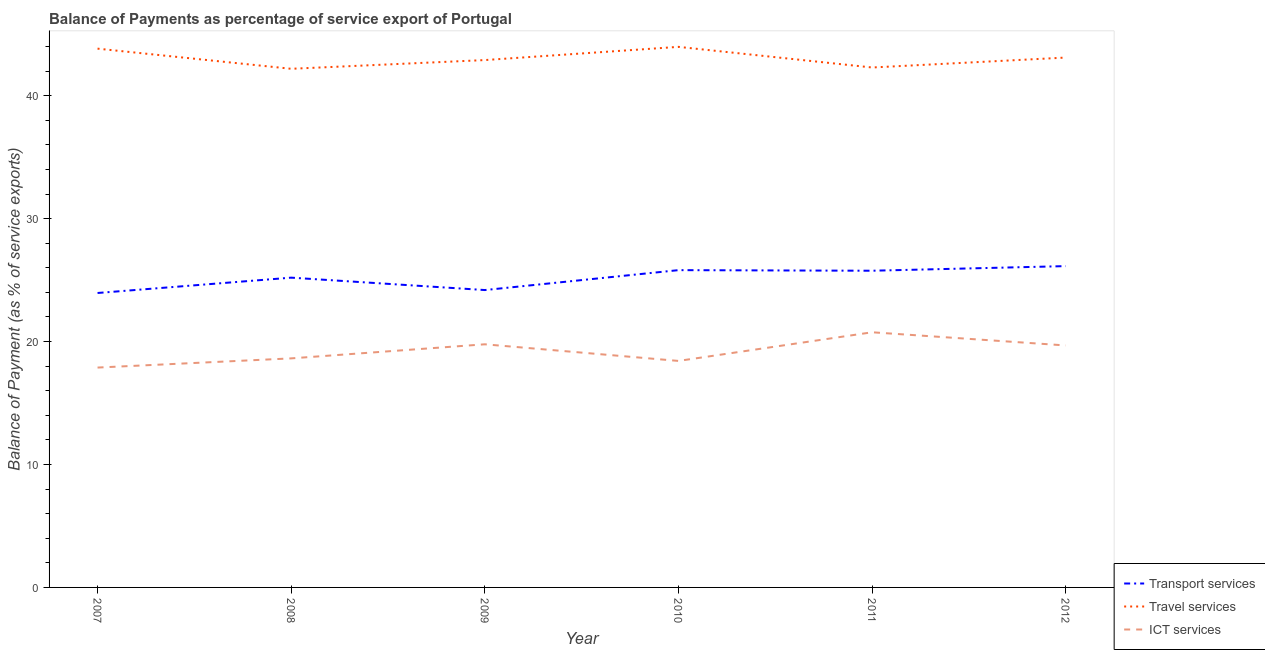How many different coloured lines are there?
Provide a short and direct response. 3. What is the balance of payment of transport services in 2007?
Provide a short and direct response. 23.95. Across all years, what is the maximum balance of payment of travel services?
Offer a terse response. 43.97. Across all years, what is the minimum balance of payment of ict services?
Your answer should be very brief. 17.89. In which year was the balance of payment of travel services maximum?
Give a very brief answer. 2010. What is the total balance of payment of travel services in the graph?
Ensure brevity in your answer.  258.29. What is the difference between the balance of payment of transport services in 2007 and that in 2008?
Give a very brief answer. -1.25. What is the difference between the balance of payment of travel services in 2010 and the balance of payment of transport services in 2011?
Ensure brevity in your answer.  18.21. What is the average balance of payment of transport services per year?
Give a very brief answer. 25.18. In the year 2010, what is the difference between the balance of payment of ict services and balance of payment of transport services?
Make the answer very short. -7.38. In how many years, is the balance of payment of transport services greater than 18 %?
Your answer should be very brief. 6. What is the ratio of the balance of payment of ict services in 2009 to that in 2012?
Your answer should be compact. 1. Is the balance of payment of travel services in 2011 less than that in 2012?
Offer a very short reply. Yes. Is the difference between the balance of payment of ict services in 2010 and 2012 greater than the difference between the balance of payment of travel services in 2010 and 2012?
Give a very brief answer. No. What is the difference between the highest and the second highest balance of payment of travel services?
Ensure brevity in your answer.  0.15. What is the difference between the highest and the lowest balance of payment of transport services?
Give a very brief answer. 2.19. Is the sum of the balance of payment of transport services in 2008 and 2010 greater than the maximum balance of payment of ict services across all years?
Ensure brevity in your answer.  Yes. Is the balance of payment of ict services strictly less than the balance of payment of travel services over the years?
Your response must be concise. Yes. How many years are there in the graph?
Give a very brief answer. 6. Are the values on the major ticks of Y-axis written in scientific E-notation?
Make the answer very short. No. How many legend labels are there?
Give a very brief answer. 3. What is the title of the graph?
Your answer should be compact. Balance of Payments as percentage of service export of Portugal. Does "Social Protection" appear as one of the legend labels in the graph?
Offer a terse response. No. What is the label or title of the Y-axis?
Give a very brief answer. Balance of Payment (as % of service exports). What is the Balance of Payment (as % of service exports) of Transport services in 2007?
Offer a very short reply. 23.95. What is the Balance of Payment (as % of service exports) of Travel services in 2007?
Offer a very short reply. 43.83. What is the Balance of Payment (as % of service exports) in ICT services in 2007?
Offer a terse response. 17.89. What is the Balance of Payment (as % of service exports) in Transport services in 2008?
Your answer should be very brief. 25.2. What is the Balance of Payment (as % of service exports) in Travel services in 2008?
Provide a succinct answer. 42.19. What is the Balance of Payment (as % of service exports) of ICT services in 2008?
Ensure brevity in your answer.  18.63. What is the Balance of Payment (as % of service exports) in Transport services in 2009?
Ensure brevity in your answer.  24.19. What is the Balance of Payment (as % of service exports) of Travel services in 2009?
Make the answer very short. 42.9. What is the Balance of Payment (as % of service exports) of ICT services in 2009?
Offer a very short reply. 19.78. What is the Balance of Payment (as % of service exports) in Transport services in 2010?
Offer a terse response. 25.81. What is the Balance of Payment (as % of service exports) in Travel services in 2010?
Give a very brief answer. 43.97. What is the Balance of Payment (as % of service exports) in ICT services in 2010?
Keep it short and to the point. 18.43. What is the Balance of Payment (as % of service exports) in Transport services in 2011?
Your answer should be very brief. 25.76. What is the Balance of Payment (as % of service exports) of Travel services in 2011?
Ensure brevity in your answer.  42.3. What is the Balance of Payment (as % of service exports) in ICT services in 2011?
Ensure brevity in your answer.  20.76. What is the Balance of Payment (as % of service exports) of Transport services in 2012?
Ensure brevity in your answer.  26.14. What is the Balance of Payment (as % of service exports) of Travel services in 2012?
Keep it short and to the point. 43.1. What is the Balance of Payment (as % of service exports) of ICT services in 2012?
Ensure brevity in your answer.  19.68. Across all years, what is the maximum Balance of Payment (as % of service exports) of Transport services?
Your answer should be very brief. 26.14. Across all years, what is the maximum Balance of Payment (as % of service exports) of Travel services?
Give a very brief answer. 43.97. Across all years, what is the maximum Balance of Payment (as % of service exports) of ICT services?
Offer a terse response. 20.76. Across all years, what is the minimum Balance of Payment (as % of service exports) in Transport services?
Offer a terse response. 23.95. Across all years, what is the minimum Balance of Payment (as % of service exports) in Travel services?
Your answer should be compact. 42.19. Across all years, what is the minimum Balance of Payment (as % of service exports) in ICT services?
Keep it short and to the point. 17.89. What is the total Balance of Payment (as % of service exports) of Transport services in the graph?
Your answer should be compact. 151.05. What is the total Balance of Payment (as % of service exports) in Travel services in the graph?
Offer a terse response. 258.29. What is the total Balance of Payment (as % of service exports) of ICT services in the graph?
Provide a short and direct response. 115.16. What is the difference between the Balance of Payment (as % of service exports) of Transport services in 2007 and that in 2008?
Your response must be concise. -1.25. What is the difference between the Balance of Payment (as % of service exports) in Travel services in 2007 and that in 2008?
Provide a succinct answer. 1.64. What is the difference between the Balance of Payment (as % of service exports) of ICT services in 2007 and that in 2008?
Ensure brevity in your answer.  -0.75. What is the difference between the Balance of Payment (as % of service exports) in Transport services in 2007 and that in 2009?
Provide a short and direct response. -0.24. What is the difference between the Balance of Payment (as % of service exports) in Travel services in 2007 and that in 2009?
Offer a terse response. 0.93. What is the difference between the Balance of Payment (as % of service exports) of ICT services in 2007 and that in 2009?
Provide a short and direct response. -1.89. What is the difference between the Balance of Payment (as % of service exports) of Transport services in 2007 and that in 2010?
Keep it short and to the point. -1.86. What is the difference between the Balance of Payment (as % of service exports) of Travel services in 2007 and that in 2010?
Provide a succinct answer. -0.14. What is the difference between the Balance of Payment (as % of service exports) of ICT services in 2007 and that in 2010?
Provide a short and direct response. -0.54. What is the difference between the Balance of Payment (as % of service exports) of Transport services in 2007 and that in 2011?
Ensure brevity in your answer.  -1.81. What is the difference between the Balance of Payment (as % of service exports) of Travel services in 2007 and that in 2011?
Offer a very short reply. 1.53. What is the difference between the Balance of Payment (as % of service exports) in ICT services in 2007 and that in 2011?
Keep it short and to the point. -2.87. What is the difference between the Balance of Payment (as % of service exports) of Transport services in 2007 and that in 2012?
Keep it short and to the point. -2.19. What is the difference between the Balance of Payment (as % of service exports) in Travel services in 2007 and that in 2012?
Keep it short and to the point. 0.73. What is the difference between the Balance of Payment (as % of service exports) in ICT services in 2007 and that in 2012?
Your answer should be compact. -1.8. What is the difference between the Balance of Payment (as % of service exports) of Transport services in 2008 and that in 2009?
Keep it short and to the point. 1.01. What is the difference between the Balance of Payment (as % of service exports) in Travel services in 2008 and that in 2009?
Give a very brief answer. -0.71. What is the difference between the Balance of Payment (as % of service exports) in ICT services in 2008 and that in 2009?
Ensure brevity in your answer.  -1.15. What is the difference between the Balance of Payment (as % of service exports) in Transport services in 2008 and that in 2010?
Offer a very short reply. -0.61. What is the difference between the Balance of Payment (as % of service exports) in Travel services in 2008 and that in 2010?
Your answer should be compact. -1.78. What is the difference between the Balance of Payment (as % of service exports) in ICT services in 2008 and that in 2010?
Make the answer very short. 0.21. What is the difference between the Balance of Payment (as % of service exports) in Transport services in 2008 and that in 2011?
Your response must be concise. -0.56. What is the difference between the Balance of Payment (as % of service exports) of Travel services in 2008 and that in 2011?
Offer a terse response. -0.11. What is the difference between the Balance of Payment (as % of service exports) of ICT services in 2008 and that in 2011?
Your answer should be very brief. -2.12. What is the difference between the Balance of Payment (as % of service exports) in Transport services in 2008 and that in 2012?
Provide a short and direct response. -0.94. What is the difference between the Balance of Payment (as % of service exports) in Travel services in 2008 and that in 2012?
Provide a succinct answer. -0.91. What is the difference between the Balance of Payment (as % of service exports) in ICT services in 2008 and that in 2012?
Your answer should be very brief. -1.05. What is the difference between the Balance of Payment (as % of service exports) of Transport services in 2009 and that in 2010?
Your answer should be very brief. -1.62. What is the difference between the Balance of Payment (as % of service exports) of Travel services in 2009 and that in 2010?
Your answer should be compact. -1.07. What is the difference between the Balance of Payment (as % of service exports) of ICT services in 2009 and that in 2010?
Ensure brevity in your answer.  1.35. What is the difference between the Balance of Payment (as % of service exports) in Transport services in 2009 and that in 2011?
Your answer should be compact. -1.57. What is the difference between the Balance of Payment (as % of service exports) of Travel services in 2009 and that in 2011?
Provide a succinct answer. 0.6. What is the difference between the Balance of Payment (as % of service exports) in ICT services in 2009 and that in 2011?
Ensure brevity in your answer.  -0.98. What is the difference between the Balance of Payment (as % of service exports) of Transport services in 2009 and that in 2012?
Offer a very short reply. -1.95. What is the difference between the Balance of Payment (as % of service exports) in Travel services in 2009 and that in 2012?
Give a very brief answer. -0.2. What is the difference between the Balance of Payment (as % of service exports) in ICT services in 2009 and that in 2012?
Give a very brief answer. 0.09. What is the difference between the Balance of Payment (as % of service exports) of Transport services in 2010 and that in 2011?
Keep it short and to the point. 0.05. What is the difference between the Balance of Payment (as % of service exports) in Travel services in 2010 and that in 2011?
Provide a succinct answer. 1.68. What is the difference between the Balance of Payment (as % of service exports) of ICT services in 2010 and that in 2011?
Provide a short and direct response. -2.33. What is the difference between the Balance of Payment (as % of service exports) in Transport services in 2010 and that in 2012?
Make the answer very short. -0.33. What is the difference between the Balance of Payment (as % of service exports) in Travel services in 2010 and that in 2012?
Provide a short and direct response. 0.87. What is the difference between the Balance of Payment (as % of service exports) of ICT services in 2010 and that in 2012?
Your answer should be compact. -1.26. What is the difference between the Balance of Payment (as % of service exports) of Transport services in 2011 and that in 2012?
Keep it short and to the point. -0.37. What is the difference between the Balance of Payment (as % of service exports) in Travel services in 2011 and that in 2012?
Offer a very short reply. -0.81. What is the difference between the Balance of Payment (as % of service exports) in ICT services in 2011 and that in 2012?
Provide a succinct answer. 1.07. What is the difference between the Balance of Payment (as % of service exports) of Transport services in 2007 and the Balance of Payment (as % of service exports) of Travel services in 2008?
Your answer should be very brief. -18.24. What is the difference between the Balance of Payment (as % of service exports) of Transport services in 2007 and the Balance of Payment (as % of service exports) of ICT services in 2008?
Your answer should be compact. 5.32. What is the difference between the Balance of Payment (as % of service exports) of Travel services in 2007 and the Balance of Payment (as % of service exports) of ICT services in 2008?
Provide a succinct answer. 25.2. What is the difference between the Balance of Payment (as % of service exports) of Transport services in 2007 and the Balance of Payment (as % of service exports) of Travel services in 2009?
Your answer should be compact. -18.95. What is the difference between the Balance of Payment (as % of service exports) of Transport services in 2007 and the Balance of Payment (as % of service exports) of ICT services in 2009?
Offer a terse response. 4.17. What is the difference between the Balance of Payment (as % of service exports) of Travel services in 2007 and the Balance of Payment (as % of service exports) of ICT services in 2009?
Provide a short and direct response. 24.05. What is the difference between the Balance of Payment (as % of service exports) in Transport services in 2007 and the Balance of Payment (as % of service exports) in Travel services in 2010?
Keep it short and to the point. -20.02. What is the difference between the Balance of Payment (as % of service exports) in Transport services in 2007 and the Balance of Payment (as % of service exports) in ICT services in 2010?
Ensure brevity in your answer.  5.53. What is the difference between the Balance of Payment (as % of service exports) in Travel services in 2007 and the Balance of Payment (as % of service exports) in ICT services in 2010?
Keep it short and to the point. 25.4. What is the difference between the Balance of Payment (as % of service exports) in Transport services in 2007 and the Balance of Payment (as % of service exports) in Travel services in 2011?
Your response must be concise. -18.34. What is the difference between the Balance of Payment (as % of service exports) in Transport services in 2007 and the Balance of Payment (as % of service exports) in ICT services in 2011?
Give a very brief answer. 3.2. What is the difference between the Balance of Payment (as % of service exports) in Travel services in 2007 and the Balance of Payment (as % of service exports) in ICT services in 2011?
Offer a very short reply. 23.07. What is the difference between the Balance of Payment (as % of service exports) of Transport services in 2007 and the Balance of Payment (as % of service exports) of Travel services in 2012?
Make the answer very short. -19.15. What is the difference between the Balance of Payment (as % of service exports) of Transport services in 2007 and the Balance of Payment (as % of service exports) of ICT services in 2012?
Your answer should be compact. 4.27. What is the difference between the Balance of Payment (as % of service exports) of Travel services in 2007 and the Balance of Payment (as % of service exports) of ICT services in 2012?
Give a very brief answer. 24.14. What is the difference between the Balance of Payment (as % of service exports) of Transport services in 2008 and the Balance of Payment (as % of service exports) of Travel services in 2009?
Give a very brief answer. -17.7. What is the difference between the Balance of Payment (as % of service exports) in Transport services in 2008 and the Balance of Payment (as % of service exports) in ICT services in 2009?
Make the answer very short. 5.42. What is the difference between the Balance of Payment (as % of service exports) of Travel services in 2008 and the Balance of Payment (as % of service exports) of ICT services in 2009?
Offer a very short reply. 22.41. What is the difference between the Balance of Payment (as % of service exports) in Transport services in 2008 and the Balance of Payment (as % of service exports) in Travel services in 2010?
Ensure brevity in your answer.  -18.77. What is the difference between the Balance of Payment (as % of service exports) in Transport services in 2008 and the Balance of Payment (as % of service exports) in ICT services in 2010?
Give a very brief answer. 6.77. What is the difference between the Balance of Payment (as % of service exports) in Travel services in 2008 and the Balance of Payment (as % of service exports) in ICT services in 2010?
Make the answer very short. 23.76. What is the difference between the Balance of Payment (as % of service exports) in Transport services in 2008 and the Balance of Payment (as % of service exports) in Travel services in 2011?
Your answer should be compact. -17.1. What is the difference between the Balance of Payment (as % of service exports) in Transport services in 2008 and the Balance of Payment (as % of service exports) in ICT services in 2011?
Your response must be concise. 4.44. What is the difference between the Balance of Payment (as % of service exports) of Travel services in 2008 and the Balance of Payment (as % of service exports) of ICT services in 2011?
Provide a succinct answer. 21.43. What is the difference between the Balance of Payment (as % of service exports) of Transport services in 2008 and the Balance of Payment (as % of service exports) of Travel services in 2012?
Offer a very short reply. -17.9. What is the difference between the Balance of Payment (as % of service exports) of Transport services in 2008 and the Balance of Payment (as % of service exports) of ICT services in 2012?
Offer a terse response. 5.52. What is the difference between the Balance of Payment (as % of service exports) in Travel services in 2008 and the Balance of Payment (as % of service exports) in ICT services in 2012?
Provide a succinct answer. 22.51. What is the difference between the Balance of Payment (as % of service exports) of Transport services in 2009 and the Balance of Payment (as % of service exports) of Travel services in 2010?
Make the answer very short. -19.78. What is the difference between the Balance of Payment (as % of service exports) in Transport services in 2009 and the Balance of Payment (as % of service exports) in ICT services in 2010?
Offer a very short reply. 5.76. What is the difference between the Balance of Payment (as % of service exports) of Travel services in 2009 and the Balance of Payment (as % of service exports) of ICT services in 2010?
Provide a succinct answer. 24.47. What is the difference between the Balance of Payment (as % of service exports) of Transport services in 2009 and the Balance of Payment (as % of service exports) of Travel services in 2011?
Your answer should be compact. -18.1. What is the difference between the Balance of Payment (as % of service exports) in Transport services in 2009 and the Balance of Payment (as % of service exports) in ICT services in 2011?
Your answer should be very brief. 3.43. What is the difference between the Balance of Payment (as % of service exports) in Travel services in 2009 and the Balance of Payment (as % of service exports) in ICT services in 2011?
Your response must be concise. 22.14. What is the difference between the Balance of Payment (as % of service exports) of Transport services in 2009 and the Balance of Payment (as % of service exports) of Travel services in 2012?
Offer a very short reply. -18.91. What is the difference between the Balance of Payment (as % of service exports) of Transport services in 2009 and the Balance of Payment (as % of service exports) of ICT services in 2012?
Offer a very short reply. 4.51. What is the difference between the Balance of Payment (as % of service exports) in Travel services in 2009 and the Balance of Payment (as % of service exports) in ICT services in 2012?
Provide a succinct answer. 23.22. What is the difference between the Balance of Payment (as % of service exports) in Transport services in 2010 and the Balance of Payment (as % of service exports) in Travel services in 2011?
Give a very brief answer. -16.49. What is the difference between the Balance of Payment (as % of service exports) of Transport services in 2010 and the Balance of Payment (as % of service exports) of ICT services in 2011?
Ensure brevity in your answer.  5.05. What is the difference between the Balance of Payment (as % of service exports) of Travel services in 2010 and the Balance of Payment (as % of service exports) of ICT services in 2011?
Offer a very short reply. 23.22. What is the difference between the Balance of Payment (as % of service exports) of Transport services in 2010 and the Balance of Payment (as % of service exports) of Travel services in 2012?
Offer a terse response. -17.29. What is the difference between the Balance of Payment (as % of service exports) of Transport services in 2010 and the Balance of Payment (as % of service exports) of ICT services in 2012?
Offer a terse response. 6.13. What is the difference between the Balance of Payment (as % of service exports) in Travel services in 2010 and the Balance of Payment (as % of service exports) in ICT services in 2012?
Offer a terse response. 24.29. What is the difference between the Balance of Payment (as % of service exports) of Transport services in 2011 and the Balance of Payment (as % of service exports) of Travel services in 2012?
Offer a very short reply. -17.34. What is the difference between the Balance of Payment (as % of service exports) in Transport services in 2011 and the Balance of Payment (as % of service exports) in ICT services in 2012?
Your response must be concise. 6.08. What is the difference between the Balance of Payment (as % of service exports) of Travel services in 2011 and the Balance of Payment (as % of service exports) of ICT services in 2012?
Provide a short and direct response. 22.61. What is the average Balance of Payment (as % of service exports) of Transport services per year?
Your response must be concise. 25.18. What is the average Balance of Payment (as % of service exports) of Travel services per year?
Offer a terse response. 43.05. What is the average Balance of Payment (as % of service exports) in ICT services per year?
Your answer should be compact. 19.19. In the year 2007, what is the difference between the Balance of Payment (as % of service exports) in Transport services and Balance of Payment (as % of service exports) in Travel services?
Make the answer very short. -19.88. In the year 2007, what is the difference between the Balance of Payment (as % of service exports) of Transport services and Balance of Payment (as % of service exports) of ICT services?
Ensure brevity in your answer.  6.07. In the year 2007, what is the difference between the Balance of Payment (as % of service exports) of Travel services and Balance of Payment (as % of service exports) of ICT services?
Your response must be concise. 25.94. In the year 2008, what is the difference between the Balance of Payment (as % of service exports) of Transport services and Balance of Payment (as % of service exports) of Travel services?
Make the answer very short. -16.99. In the year 2008, what is the difference between the Balance of Payment (as % of service exports) in Transport services and Balance of Payment (as % of service exports) in ICT services?
Your response must be concise. 6.57. In the year 2008, what is the difference between the Balance of Payment (as % of service exports) in Travel services and Balance of Payment (as % of service exports) in ICT services?
Make the answer very short. 23.56. In the year 2009, what is the difference between the Balance of Payment (as % of service exports) of Transport services and Balance of Payment (as % of service exports) of Travel services?
Make the answer very short. -18.71. In the year 2009, what is the difference between the Balance of Payment (as % of service exports) in Transport services and Balance of Payment (as % of service exports) in ICT services?
Keep it short and to the point. 4.41. In the year 2009, what is the difference between the Balance of Payment (as % of service exports) of Travel services and Balance of Payment (as % of service exports) of ICT services?
Offer a very short reply. 23.12. In the year 2010, what is the difference between the Balance of Payment (as % of service exports) of Transport services and Balance of Payment (as % of service exports) of Travel services?
Give a very brief answer. -18.16. In the year 2010, what is the difference between the Balance of Payment (as % of service exports) of Transport services and Balance of Payment (as % of service exports) of ICT services?
Provide a succinct answer. 7.38. In the year 2010, what is the difference between the Balance of Payment (as % of service exports) of Travel services and Balance of Payment (as % of service exports) of ICT services?
Provide a succinct answer. 25.55. In the year 2011, what is the difference between the Balance of Payment (as % of service exports) of Transport services and Balance of Payment (as % of service exports) of Travel services?
Give a very brief answer. -16.53. In the year 2011, what is the difference between the Balance of Payment (as % of service exports) of Transport services and Balance of Payment (as % of service exports) of ICT services?
Ensure brevity in your answer.  5.01. In the year 2011, what is the difference between the Balance of Payment (as % of service exports) in Travel services and Balance of Payment (as % of service exports) in ICT services?
Give a very brief answer. 21.54. In the year 2012, what is the difference between the Balance of Payment (as % of service exports) of Transport services and Balance of Payment (as % of service exports) of Travel services?
Keep it short and to the point. -16.97. In the year 2012, what is the difference between the Balance of Payment (as % of service exports) in Transport services and Balance of Payment (as % of service exports) in ICT services?
Your answer should be very brief. 6.45. In the year 2012, what is the difference between the Balance of Payment (as % of service exports) in Travel services and Balance of Payment (as % of service exports) in ICT services?
Your answer should be compact. 23.42. What is the ratio of the Balance of Payment (as % of service exports) of Transport services in 2007 to that in 2008?
Provide a short and direct response. 0.95. What is the ratio of the Balance of Payment (as % of service exports) of Travel services in 2007 to that in 2008?
Provide a short and direct response. 1.04. What is the ratio of the Balance of Payment (as % of service exports) in ICT services in 2007 to that in 2008?
Your response must be concise. 0.96. What is the ratio of the Balance of Payment (as % of service exports) in Transport services in 2007 to that in 2009?
Your response must be concise. 0.99. What is the ratio of the Balance of Payment (as % of service exports) of Travel services in 2007 to that in 2009?
Provide a succinct answer. 1.02. What is the ratio of the Balance of Payment (as % of service exports) in ICT services in 2007 to that in 2009?
Offer a terse response. 0.9. What is the ratio of the Balance of Payment (as % of service exports) of Transport services in 2007 to that in 2010?
Keep it short and to the point. 0.93. What is the ratio of the Balance of Payment (as % of service exports) of ICT services in 2007 to that in 2010?
Give a very brief answer. 0.97. What is the ratio of the Balance of Payment (as % of service exports) in Transport services in 2007 to that in 2011?
Your answer should be very brief. 0.93. What is the ratio of the Balance of Payment (as % of service exports) of Travel services in 2007 to that in 2011?
Ensure brevity in your answer.  1.04. What is the ratio of the Balance of Payment (as % of service exports) in ICT services in 2007 to that in 2011?
Offer a very short reply. 0.86. What is the ratio of the Balance of Payment (as % of service exports) of Transport services in 2007 to that in 2012?
Provide a short and direct response. 0.92. What is the ratio of the Balance of Payment (as % of service exports) in Travel services in 2007 to that in 2012?
Your answer should be compact. 1.02. What is the ratio of the Balance of Payment (as % of service exports) of ICT services in 2007 to that in 2012?
Give a very brief answer. 0.91. What is the ratio of the Balance of Payment (as % of service exports) of Transport services in 2008 to that in 2009?
Your answer should be very brief. 1.04. What is the ratio of the Balance of Payment (as % of service exports) of Travel services in 2008 to that in 2009?
Your answer should be very brief. 0.98. What is the ratio of the Balance of Payment (as % of service exports) in ICT services in 2008 to that in 2009?
Ensure brevity in your answer.  0.94. What is the ratio of the Balance of Payment (as % of service exports) in Transport services in 2008 to that in 2010?
Keep it short and to the point. 0.98. What is the ratio of the Balance of Payment (as % of service exports) in Travel services in 2008 to that in 2010?
Offer a very short reply. 0.96. What is the ratio of the Balance of Payment (as % of service exports) in ICT services in 2008 to that in 2010?
Provide a succinct answer. 1.01. What is the ratio of the Balance of Payment (as % of service exports) of Transport services in 2008 to that in 2011?
Provide a short and direct response. 0.98. What is the ratio of the Balance of Payment (as % of service exports) of Travel services in 2008 to that in 2011?
Your response must be concise. 1. What is the ratio of the Balance of Payment (as % of service exports) in ICT services in 2008 to that in 2011?
Your answer should be compact. 0.9. What is the ratio of the Balance of Payment (as % of service exports) of Transport services in 2008 to that in 2012?
Make the answer very short. 0.96. What is the ratio of the Balance of Payment (as % of service exports) in Travel services in 2008 to that in 2012?
Ensure brevity in your answer.  0.98. What is the ratio of the Balance of Payment (as % of service exports) of ICT services in 2008 to that in 2012?
Offer a terse response. 0.95. What is the ratio of the Balance of Payment (as % of service exports) in Transport services in 2009 to that in 2010?
Provide a short and direct response. 0.94. What is the ratio of the Balance of Payment (as % of service exports) of Travel services in 2009 to that in 2010?
Keep it short and to the point. 0.98. What is the ratio of the Balance of Payment (as % of service exports) of ICT services in 2009 to that in 2010?
Offer a terse response. 1.07. What is the ratio of the Balance of Payment (as % of service exports) in Transport services in 2009 to that in 2011?
Provide a succinct answer. 0.94. What is the ratio of the Balance of Payment (as % of service exports) in Travel services in 2009 to that in 2011?
Make the answer very short. 1.01. What is the ratio of the Balance of Payment (as % of service exports) in ICT services in 2009 to that in 2011?
Your answer should be compact. 0.95. What is the ratio of the Balance of Payment (as % of service exports) of Transport services in 2009 to that in 2012?
Your response must be concise. 0.93. What is the ratio of the Balance of Payment (as % of service exports) of ICT services in 2009 to that in 2012?
Provide a short and direct response. 1. What is the ratio of the Balance of Payment (as % of service exports) in Transport services in 2010 to that in 2011?
Offer a very short reply. 1. What is the ratio of the Balance of Payment (as % of service exports) of Travel services in 2010 to that in 2011?
Provide a short and direct response. 1.04. What is the ratio of the Balance of Payment (as % of service exports) in ICT services in 2010 to that in 2011?
Ensure brevity in your answer.  0.89. What is the ratio of the Balance of Payment (as % of service exports) of Transport services in 2010 to that in 2012?
Offer a very short reply. 0.99. What is the ratio of the Balance of Payment (as % of service exports) in Travel services in 2010 to that in 2012?
Ensure brevity in your answer.  1.02. What is the ratio of the Balance of Payment (as % of service exports) in ICT services in 2010 to that in 2012?
Your answer should be compact. 0.94. What is the ratio of the Balance of Payment (as % of service exports) of Transport services in 2011 to that in 2012?
Provide a succinct answer. 0.99. What is the ratio of the Balance of Payment (as % of service exports) of Travel services in 2011 to that in 2012?
Provide a succinct answer. 0.98. What is the ratio of the Balance of Payment (as % of service exports) in ICT services in 2011 to that in 2012?
Provide a short and direct response. 1.05. What is the difference between the highest and the second highest Balance of Payment (as % of service exports) in Transport services?
Your answer should be very brief. 0.33. What is the difference between the highest and the second highest Balance of Payment (as % of service exports) of Travel services?
Make the answer very short. 0.14. What is the difference between the highest and the second highest Balance of Payment (as % of service exports) in ICT services?
Provide a short and direct response. 0.98. What is the difference between the highest and the lowest Balance of Payment (as % of service exports) in Transport services?
Make the answer very short. 2.19. What is the difference between the highest and the lowest Balance of Payment (as % of service exports) in Travel services?
Ensure brevity in your answer.  1.78. What is the difference between the highest and the lowest Balance of Payment (as % of service exports) in ICT services?
Give a very brief answer. 2.87. 